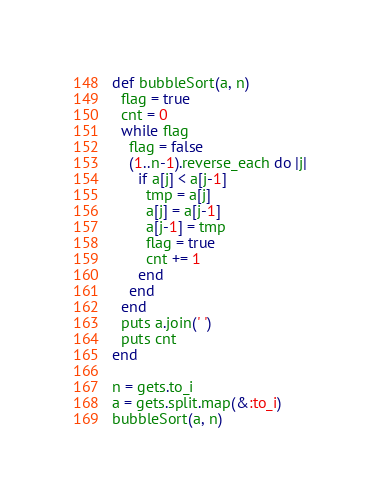<code> <loc_0><loc_0><loc_500><loc_500><_Ruby_>def bubbleSort(a, n)
  flag = true
  cnt = 0
  while flag
    flag = false
    (1..n-1).reverse_each do |j|
      if a[j] < a[j-1]
        tmp = a[j]
        a[j] = a[j-1]
        a[j-1] = tmp
        flag = true
        cnt += 1
      end
    end
  end
  puts a.join(' ')
  puts cnt
end

n = gets.to_i
a = gets.split.map(&:to_i)
bubbleSort(a, n)
</code> 